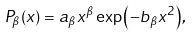Convert formula to latex. <formula><loc_0><loc_0><loc_500><loc_500>P _ { \beta } ( x ) = a _ { \beta } x ^ { \beta } \exp { \left ( - b _ { \beta } x ^ { 2 } \right ) } ,</formula> 